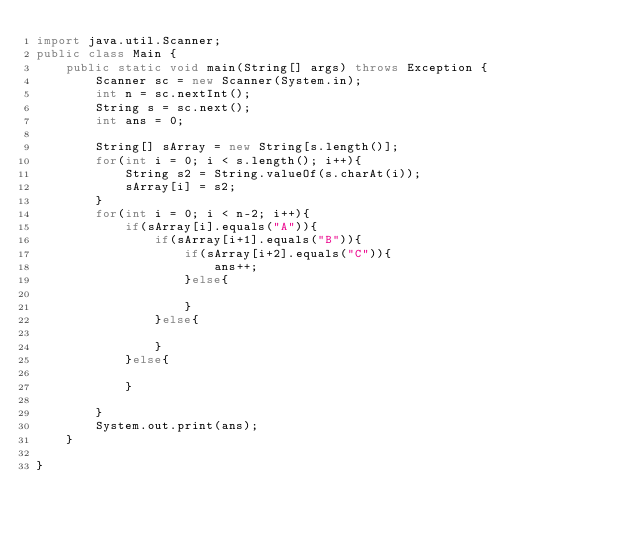Convert code to text. <code><loc_0><loc_0><loc_500><loc_500><_Java_>import java.util.Scanner;
public class Main {
    public static void main(String[] args) throws Exception {
        Scanner sc = new Scanner(System.in);
        int n = sc.nextInt();
        String s = sc.next();
        int ans = 0;
        
        String[] sArray = new String[s.length()];
        for(int i = 0; i < s.length(); i++){
            String s2 = String.valueOf(s.charAt(i));
            sArray[i] = s2;
        }
        for(int i = 0; i < n-2; i++){
            if(sArray[i].equals("A")){
                if(sArray[i+1].equals("B")){
                    if(sArray[i+2].equals("C")){
                        ans++;
                    }else{
                        
                    }
                }else{
                    
                }
            }else{
                
            }
            
        }
        System.out.print(ans);
    }
           
}</code> 